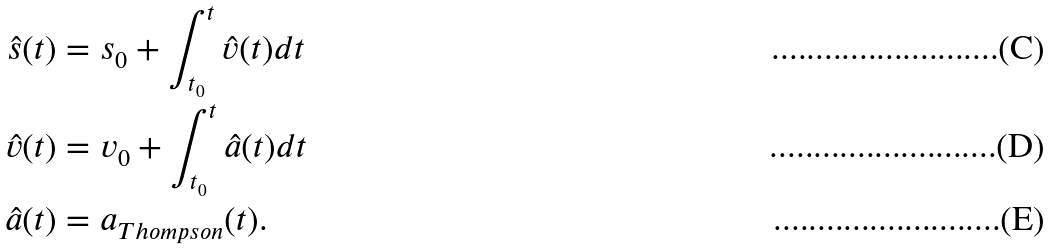<formula> <loc_0><loc_0><loc_500><loc_500>\hat { s } ( t ) & = s _ { 0 } + \int _ { t _ { 0 } } ^ { t } \hat { v } ( t ) d t \\ \hat { v } ( t ) & = v _ { 0 } + \int _ { t _ { 0 } } ^ { t } \hat { a } ( t ) d t \\ \hat { a } ( t ) & = a _ { T h o m p s o n } ( t ) .</formula> 